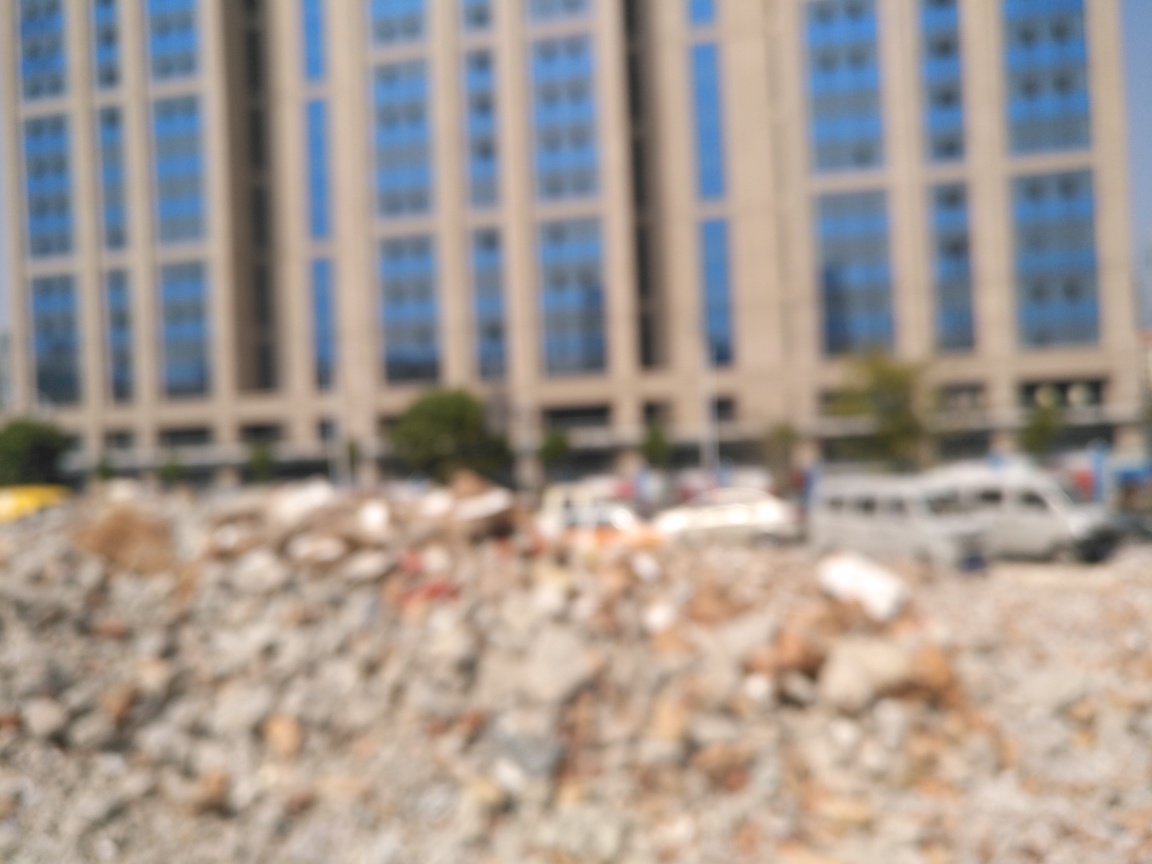What can we infer about the location or time of day in the image? Despite the lack of clarity, the lighting suggests it could be daytime. As for the location, the presence of a large building and the rubble suggest an urban setting, possibly undergoing development or reconstruction. However, without clear identifiers like signage or recognizable landmarks, the exact location remains uncertain. 